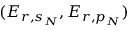Convert formula to latex. <formula><loc_0><loc_0><loc_500><loc_500>( E _ { r , s _ { N } } , E _ { r , p _ { N } } )</formula> 